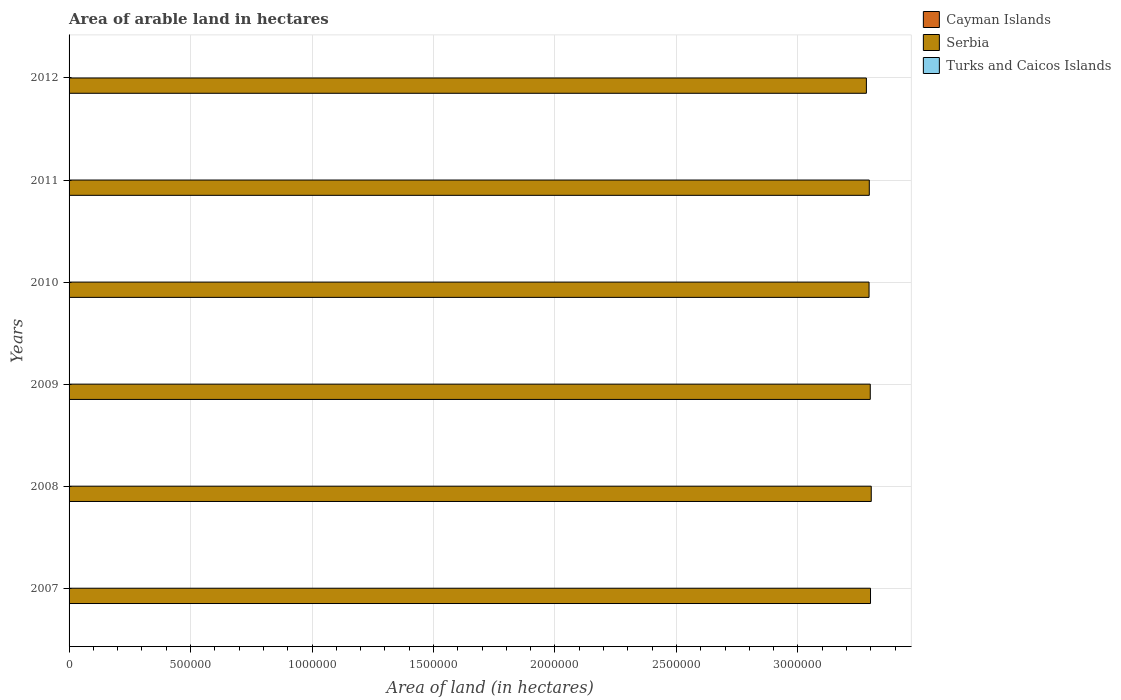How many groups of bars are there?
Your answer should be compact. 6. Are the number of bars on each tick of the Y-axis equal?
Make the answer very short. Yes. How many bars are there on the 1st tick from the bottom?
Your answer should be compact. 3. What is the total arable land in Serbia in 2010?
Offer a terse response. 3.29e+06. Across all years, what is the maximum total arable land in Serbia?
Ensure brevity in your answer.  3.30e+06. Across all years, what is the minimum total arable land in Serbia?
Keep it short and to the point. 3.28e+06. In which year was the total arable land in Turks and Caicos Islands minimum?
Ensure brevity in your answer.  2007. What is the total total arable land in Turks and Caicos Islands in the graph?
Provide a succinct answer. 6000. What is the difference between the total arable land in Cayman Islands in 2009 and the total arable land in Serbia in 2008?
Your answer should be very brief. -3.30e+06. What is the average total arable land in Cayman Islands per year?
Ensure brevity in your answer.  200. In the year 2011, what is the difference between the total arable land in Serbia and total arable land in Turks and Caicos Islands?
Your response must be concise. 3.29e+06. In how many years, is the total arable land in Serbia greater than 600000 hectares?
Your answer should be compact. 6. Is the total arable land in Turks and Caicos Islands in 2007 less than that in 2008?
Your answer should be compact. No. In how many years, is the total arable land in Cayman Islands greater than the average total arable land in Cayman Islands taken over all years?
Give a very brief answer. 0. Is the sum of the total arable land in Cayman Islands in 2007 and 2008 greater than the maximum total arable land in Serbia across all years?
Offer a terse response. No. What does the 3rd bar from the top in 2008 represents?
Provide a short and direct response. Cayman Islands. What does the 3rd bar from the bottom in 2009 represents?
Offer a very short reply. Turks and Caicos Islands. How many bars are there?
Keep it short and to the point. 18. Are all the bars in the graph horizontal?
Offer a very short reply. Yes. What is the difference between two consecutive major ticks on the X-axis?
Give a very brief answer. 5.00e+05. Are the values on the major ticks of X-axis written in scientific E-notation?
Your answer should be compact. No. Does the graph contain any zero values?
Give a very brief answer. No. Does the graph contain grids?
Provide a succinct answer. Yes. What is the title of the graph?
Give a very brief answer. Area of arable land in hectares. Does "Bolivia" appear as one of the legend labels in the graph?
Provide a short and direct response. No. What is the label or title of the X-axis?
Keep it short and to the point. Area of land (in hectares). What is the label or title of the Y-axis?
Your response must be concise. Years. What is the Area of land (in hectares) in Serbia in 2007?
Provide a succinct answer. 3.30e+06. What is the Area of land (in hectares) of Serbia in 2008?
Your response must be concise. 3.30e+06. What is the Area of land (in hectares) in Cayman Islands in 2009?
Your response must be concise. 200. What is the Area of land (in hectares) of Serbia in 2009?
Offer a terse response. 3.30e+06. What is the Area of land (in hectares) of Cayman Islands in 2010?
Give a very brief answer. 200. What is the Area of land (in hectares) of Serbia in 2010?
Make the answer very short. 3.29e+06. What is the Area of land (in hectares) in Turks and Caicos Islands in 2010?
Your answer should be very brief. 1000. What is the Area of land (in hectares) of Serbia in 2011?
Give a very brief answer. 3.29e+06. What is the Area of land (in hectares) of Cayman Islands in 2012?
Provide a succinct answer. 200. What is the Area of land (in hectares) of Serbia in 2012?
Your response must be concise. 3.28e+06. Across all years, what is the maximum Area of land (in hectares) of Cayman Islands?
Keep it short and to the point. 200. Across all years, what is the maximum Area of land (in hectares) in Serbia?
Your response must be concise. 3.30e+06. Across all years, what is the maximum Area of land (in hectares) of Turks and Caicos Islands?
Keep it short and to the point. 1000. Across all years, what is the minimum Area of land (in hectares) of Serbia?
Your answer should be very brief. 3.28e+06. Across all years, what is the minimum Area of land (in hectares) in Turks and Caicos Islands?
Offer a terse response. 1000. What is the total Area of land (in hectares) of Cayman Islands in the graph?
Keep it short and to the point. 1200. What is the total Area of land (in hectares) in Serbia in the graph?
Ensure brevity in your answer.  1.98e+07. What is the total Area of land (in hectares) in Turks and Caicos Islands in the graph?
Offer a very short reply. 6000. What is the difference between the Area of land (in hectares) of Serbia in 2007 and that in 2008?
Your response must be concise. -3000. What is the difference between the Area of land (in hectares) in Turks and Caicos Islands in 2007 and that in 2008?
Offer a very short reply. 0. What is the difference between the Area of land (in hectares) of Serbia in 2007 and that in 2009?
Offer a terse response. 1000. What is the difference between the Area of land (in hectares) in Turks and Caicos Islands in 2007 and that in 2009?
Provide a succinct answer. 0. What is the difference between the Area of land (in hectares) of Cayman Islands in 2007 and that in 2010?
Your answer should be very brief. 0. What is the difference between the Area of land (in hectares) in Serbia in 2007 and that in 2010?
Offer a terse response. 6000. What is the difference between the Area of land (in hectares) in Turks and Caicos Islands in 2007 and that in 2010?
Your answer should be compact. 0. What is the difference between the Area of land (in hectares) of Turks and Caicos Islands in 2007 and that in 2011?
Keep it short and to the point. 0. What is the difference between the Area of land (in hectares) of Serbia in 2007 and that in 2012?
Keep it short and to the point. 1.70e+04. What is the difference between the Area of land (in hectares) of Cayman Islands in 2008 and that in 2009?
Your answer should be compact. 0. What is the difference between the Area of land (in hectares) in Serbia in 2008 and that in 2009?
Give a very brief answer. 4000. What is the difference between the Area of land (in hectares) in Turks and Caicos Islands in 2008 and that in 2009?
Provide a succinct answer. 0. What is the difference between the Area of land (in hectares) in Cayman Islands in 2008 and that in 2010?
Offer a terse response. 0. What is the difference between the Area of land (in hectares) in Serbia in 2008 and that in 2010?
Provide a short and direct response. 9000. What is the difference between the Area of land (in hectares) of Cayman Islands in 2008 and that in 2011?
Your response must be concise. 0. What is the difference between the Area of land (in hectares) of Serbia in 2008 and that in 2011?
Ensure brevity in your answer.  8000. What is the difference between the Area of land (in hectares) of Turks and Caicos Islands in 2008 and that in 2011?
Ensure brevity in your answer.  0. What is the difference between the Area of land (in hectares) in Cayman Islands in 2008 and that in 2012?
Provide a short and direct response. 0. What is the difference between the Area of land (in hectares) of Turks and Caicos Islands in 2008 and that in 2012?
Your answer should be very brief. 0. What is the difference between the Area of land (in hectares) in Cayman Islands in 2009 and that in 2010?
Give a very brief answer. 0. What is the difference between the Area of land (in hectares) in Serbia in 2009 and that in 2010?
Provide a succinct answer. 5000. What is the difference between the Area of land (in hectares) of Turks and Caicos Islands in 2009 and that in 2010?
Your answer should be compact. 0. What is the difference between the Area of land (in hectares) in Serbia in 2009 and that in 2011?
Make the answer very short. 4000. What is the difference between the Area of land (in hectares) of Turks and Caicos Islands in 2009 and that in 2011?
Provide a succinct answer. 0. What is the difference between the Area of land (in hectares) of Cayman Islands in 2009 and that in 2012?
Ensure brevity in your answer.  0. What is the difference between the Area of land (in hectares) of Serbia in 2009 and that in 2012?
Your answer should be very brief. 1.60e+04. What is the difference between the Area of land (in hectares) in Turks and Caicos Islands in 2009 and that in 2012?
Offer a very short reply. 0. What is the difference between the Area of land (in hectares) in Cayman Islands in 2010 and that in 2011?
Your response must be concise. 0. What is the difference between the Area of land (in hectares) of Serbia in 2010 and that in 2011?
Ensure brevity in your answer.  -1000. What is the difference between the Area of land (in hectares) in Cayman Islands in 2010 and that in 2012?
Your answer should be compact. 0. What is the difference between the Area of land (in hectares) of Serbia in 2010 and that in 2012?
Offer a terse response. 1.10e+04. What is the difference between the Area of land (in hectares) of Turks and Caicos Islands in 2010 and that in 2012?
Your answer should be very brief. 0. What is the difference between the Area of land (in hectares) in Cayman Islands in 2011 and that in 2012?
Your response must be concise. 0. What is the difference between the Area of land (in hectares) in Serbia in 2011 and that in 2012?
Ensure brevity in your answer.  1.20e+04. What is the difference between the Area of land (in hectares) in Turks and Caicos Islands in 2011 and that in 2012?
Your answer should be compact. 0. What is the difference between the Area of land (in hectares) in Cayman Islands in 2007 and the Area of land (in hectares) in Serbia in 2008?
Make the answer very short. -3.30e+06. What is the difference between the Area of land (in hectares) of Cayman Islands in 2007 and the Area of land (in hectares) of Turks and Caicos Islands in 2008?
Offer a terse response. -800. What is the difference between the Area of land (in hectares) of Serbia in 2007 and the Area of land (in hectares) of Turks and Caicos Islands in 2008?
Give a very brief answer. 3.30e+06. What is the difference between the Area of land (in hectares) in Cayman Islands in 2007 and the Area of land (in hectares) in Serbia in 2009?
Provide a succinct answer. -3.30e+06. What is the difference between the Area of land (in hectares) of Cayman Islands in 2007 and the Area of land (in hectares) of Turks and Caicos Islands in 2009?
Keep it short and to the point. -800. What is the difference between the Area of land (in hectares) in Serbia in 2007 and the Area of land (in hectares) in Turks and Caicos Islands in 2009?
Provide a succinct answer. 3.30e+06. What is the difference between the Area of land (in hectares) in Cayman Islands in 2007 and the Area of land (in hectares) in Serbia in 2010?
Provide a succinct answer. -3.29e+06. What is the difference between the Area of land (in hectares) in Cayman Islands in 2007 and the Area of land (in hectares) in Turks and Caicos Islands in 2010?
Ensure brevity in your answer.  -800. What is the difference between the Area of land (in hectares) of Serbia in 2007 and the Area of land (in hectares) of Turks and Caicos Islands in 2010?
Your answer should be compact. 3.30e+06. What is the difference between the Area of land (in hectares) in Cayman Islands in 2007 and the Area of land (in hectares) in Serbia in 2011?
Keep it short and to the point. -3.29e+06. What is the difference between the Area of land (in hectares) in Cayman Islands in 2007 and the Area of land (in hectares) in Turks and Caicos Islands in 2011?
Your response must be concise. -800. What is the difference between the Area of land (in hectares) of Serbia in 2007 and the Area of land (in hectares) of Turks and Caicos Islands in 2011?
Your response must be concise. 3.30e+06. What is the difference between the Area of land (in hectares) of Cayman Islands in 2007 and the Area of land (in hectares) of Serbia in 2012?
Provide a short and direct response. -3.28e+06. What is the difference between the Area of land (in hectares) of Cayman Islands in 2007 and the Area of land (in hectares) of Turks and Caicos Islands in 2012?
Keep it short and to the point. -800. What is the difference between the Area of land (in hectares) of Serbia in 2007 and the Area of land (in hectares) of Turks and Caicos Islands in 2012?
Provide a short and direct response. 3.30e+06. What is the difference between the Area of land (in hectares) of Cayman Islands in 2008 and the Area of land (in hectares) of Serbia in 2009?
Provide a succinct answer. -3.30e+06. What is the difference between the Area of land (in hectares) of Cayman Islands in 2008 and the Area of land (in hectares) of Turks and Caicos Islands in 2009?
Give a very brief answer. -800. What is the difference between the Area of land (in hectares) in Serbia in 2008 and the Area of land (in hectares) in Turks and Caicos Islands in 2009?
Provide a short and direct response. 3.30e+06. What is the difference between the Area of land (in hectares) in Cayman Islands in 2008 and the Area of land (in hectares) in Serbia in 2010?
Provide a succinct answer. -3.29e+06. What is the difference between the Area of land (in hectares) of Cayman Islands in 2008 and the Area of land (in hectares) of Turks and Caicos Islands in 2010?
Offer a terse response. -800. What is the difference between the Area of land (in hectares) in Serbia in 2008 and the Area of land (in hectares) in Turks and Caicos Islands in 2010?
Your response must be concise. 3.30e+06. What is the difference between the Area of land (in hectares) of Cayman Islands in 2008 and the Area of land (in hectares) of Serbia in 2011?
Provide a succinct answer. -3.29e+06. What is the difference between the Area of land (in hectares) in Cayman Islands in 2008 and the Area of land (in hectares) in Turks and Caicos Islands in 2011?
Keep it short and to the point. -800. What is the difference between the Area of land (in hectares) in Serbia in 2008 and the Area of land (in hectares) in Turks and Caicos Islands in 2011?
Ensure brevity in your answer.  3.30e+06. What is the difference between the Area of land (in hectares) of Cayman Islands in 2008 and the Area of land (in hectares) of Serbia in 2012?
Offer a terse response. -3.28e+06. What is the difference between the Area of land (in hectares) in Cayman Islands in 2008 and the Area of land (in hectares) in Turks and Caicos Islands in 2012?
Provide a short and direct response. -800. What is the difference between the Area of land (in hectares) in Serbia in 2008 and the Area of land (in hectares) in Turks and Caicos Islands in 2012?
Keep it short and to the point. 3.30e+06. What is the difference between the Area of land (in hectares) in Cayman Islands in 2009 and the Area of land (in hectares) in Serbia in 2010?
Provide a succinct answer. -3.29e+06. What is the difference between the Area of land (in hectares) in Cayman Islands in 2009 and the Area of land (in hectares) in Turks and Caicos Islands in 2010?
Keep it short and to the point. -800. What is the difference between the Area of land (in hectares) in Serbia in 2009 and the Area of land (in hectares) in Turks and Caicos Islands in 2010?
Provide a short and direct response. 3.30e+06. What is the difference between the Area of land (in hectares) in Cayman Islands in 2009 and the Area of land (in hectares) in Serbia in 2011?
Provide a short and direct response. -3.29e+06. What is the difference between the Area of land (in hectares) of Cayman Islands in 2009 and the Area of land (in hectares) of Turks and Caicos Islands in 2011?
Make the answer very short. -800. What is the difference between the Area of land (in hectares) of Serbia in 2009 and the Area of land (in hectares) of Turks and Caicos Islands in 2011?
Offer a very short reply. 3.30e+06. What is the difference between the Area of land (in hectares) in Cayman Islands in 2009 and the Area of land (in hectares) in Serbia in 2012?
Keep it short and to the point. -3.28e+06. What is the difference between the Area of land (in hectares) of Cayman Islands in 2009 and the Area of land (in hectares) of Turks and Caicos Islands in 2012?
Your answer should be very brief. -800. What is the difference between the Area of land (in hectares) in Serbia in 2009 and the Area of land (in hectares) in Turks and Caicos Islands in 2012?
Offer a terse response. 3.30e+06. What is the difference between the Area of land (in hectares) of Cayman Islands in 2010 and the Area of land (in hectares) of Serbia in 2011?
Your response must be concise. -3.29e+06. What is the difference between the Area of land (in hectares) of Cayman Islands in 2010 and the Area of land (in hectares) of Turks and Caicos Islands in 2011?
Your answer should be compact. -800. What is the difference between the Area of land (in hectares) in Serbia in 2010 and the Area of land (in hectares) in Turks and Caicos Islands in 2011?
Provide a succinct answer. 3.29e+06. What is the difference between the Area of land (in hectares) in Cayman Islands in 2010 and the Area of land (in hectares) in Serbia in 2012?
Give a very brief answer. -3.28e+06. What is the difference between the Area of land (in hectares) in Cayman Islands in 2010 and the Area of land (in hectares) in Turks and Caicos Islands in 2012?
Make the answer very short. -800. What is the difference between the Area of land (in hectares) of Serbia in 2010 and the Area of land (in hectares) of Turks and Caicos Islands in 2012?
Make the answer very short. 3.29e+06. What is the difference between the Area of land (in hectares) of Cayman Islands in 2011 and the Area of land (in hectares) of Serbia in 2012?
Provide a succinct answer. -3.28e+06. What is the difference between the Area of land (in hectares) in Cayman Islands in 2011 and the Area of land (in hectares) in Turks and Caicos Islands in 2012?
Your answer should be compact. -800. What is the difference between the Area of land (in hectares) in Serbia in 2011 and the Area of land (in hectares) in Turks and Caicos Islands in 2012?
Ensure brevity in your answer.  3.29e+06. What is the average Area of land (in hectares) of Cayman Islands per year?
Give a very brief answer. 200. What is the average Area of land (in hectares) in Serbia per year?
Your answer should be compact. 3.29e+06. In the year 2007, what is the difference between the Area of land (in hectares) in Cayman Islands and Area of land (in hectares) in Serbia?
Offer a very short reply. -3.30e+06. In the year 2007, what is the difference between the Area of land (in hectares) in Cayman Islands and Area of land (in hectares) in Turks and Caicos Islands?
Your response must be concise. -800. In the year 2007, what is the difference between the Area of land (in hectares) of Serbia and Area of land (in hectares) of Turks and Caicos Islands?
Provide a short and direct response. 3.30e+06. In the year 2008, what is the difference between the Area of land (in hectares) in Cayman Islands and Area of land (in hectares) in Serbia?
Your answer should be compact. -3.30e+06. In the year 2008, what is the difference between the Area of land (in hectares) in Cayman Islands and Area of land (in hectares) in Turks and Caicos Islands?
Your answer should be compact. -800. In the year 2008, what is the difference between the Area of land (in hectares) in Serbia and Area of land (in hectares) in Turks and Caicos Islands?
Provide a succinct answer. 3.30e+06. In the year 2009, what is the difference between the Area of land (in hectares) of Cayman Islands and Area of land (in hectares) of Serbia?
Make the answer very short. -3.30e+06. In the year 2009, what is the difference between the Area of land (in hectares) of Cayman Islands and Area of land (in hectares) of Turks and Caicos Islands?
Ensure brevity in your answer.  -800. In the year 2009, what is the difference between the Area of land (in hectares) in Serbia and Area of land (in hectares) in Turks and Caicos Islands?
Make the answer very short. 3.30e+06. In the year 2010, what is the difference between the Area of land (in hectares) of Cayman Islands and Area of land (in hectares) of Serbia?
Provide a short and direct response. -3.29e+06. In the year 2010, what is the difference between the Area of land (in hectares) of Cayman Islands and Area of land (in hectares) of Turks and Caicos Islands?
Offer a terse response. -800. In the year 2010, what is the difference between the Area of land (in hectares) of Serbia and Area of land (in hectares) of Turks and Caicos Islands?
Give a very brief answer. 3.29e+06. In the year 2011, what is the difference between the Area of land (in hectares) in Cayman Islands and Area of land (in hectares) in Serbia?
Ensure brevity in your answer.  -3.29e+06. In the year 2011, what is the difference between the Area of land (in hectares) in Cayman Islands and Area of land (in hectares) in Turks and Caicos Islands?
Your answer should be compact. -800. In the year 2011, what is the difference between the Area of land (in hectares) in Serbia and Area of land (in hectares) in Turks and Caicos Islands?
Ensure brevity in your answer.  3.29e+06. In the year 2012, what is the difference between the Area of land (in hectares) in Cayman Islands and Area of land (in hectares) in Serbia?
Ensure brevity in your answer.  -3.28e+06. In the year 2012, what is the difference between the Area of land (in hectares) in Cayman Islands and Area of land (in hectares) in Turks and Caicos Islands?
Offer a terse response. -800. In the year 2012, what is the difference between the Area of land (in hectares) in Serbia and Area of land (in hectares) in Turks and Caicos Islands?
Your answer should be very brief. 3.28e+06. What is the ratio of the Area of land (in hectares) in Cayman Islands in 2007 to that in 2009?
Your answer should be compact. 1. What is the ratio of the Area of land (in hectares) in Serbia in 2007 to that in 2009?
Offer a very short reply. 1. What is the ratio of the Area of land (in hectares) in Serbia in 2007 to that in 2011?
Provide a succinct answer. 1. What is the ratio of the Area of land (in hectares) of Turks and Caicos Islands in 2007 to that in 2011?
Offer a very short reply. 1. What is the ratio of the Area of land (in hectares) in Turks and Caicos Islands in 2007 to that in 2012?
Make the answer very short. 1. What is the ratio of the Area of land (in hectares) of Cayman Islands in 2008 to that in 2010?
Your answer should be very brief. 1. What is the ratio of the Area of land (in hectares) in Turks and Caicos Islands in 2008 to that in 2010?
Offer a terse response. 1. What is the ratio of the Area of land (in hectares) in Cayman Islands in 2008 to that in 2011?
Your answer should be compact. 1. What is the ratio of the Area of land (in hectares) of Cayman Islands in 2008 to that in 2012?
Give a very brief answer. 1. What is the ratio of the Area of land (in hectares) in Serbia in 2008 to that in 2012?
Offer a terse response. 1.01. What is the ratio of the Area of land (in hectares) of Turks and Caicos Islands in 2008 to that in 2012?
Provide a succinct answer. 1. What is the ratio of the Area of land (in hectares) in Serbia in 2009 to that in 2010?
Ensure brevity in your answer.  1. What is the ratio of the Area of land (in hectares) in Cayman Islands in 2009 to that in 2011?
Provide a succinct answer. 1. What is the ratio of the Area of land (in hectares) in Serbia in 2009 to that in 2011?
Make the answer very short. 1. What is the ratio of the Area of land (in hectares) of Turks and Caicos Islands in 2009 to that in 2011?
Ensure brevity in your answer.  1. What is the ratio of the Area of land (in hectares) in Cayman Islands in 2010 to that in 2012?
Your response must be concise. 1. What is the ratio of the Area of land (in hectares) of Turks and Caicos Islands in 2010 to that in 2012?
Your answer should be very brief. 1. What is the ratio of the Area of land (in hectares) of Cayman Islands in 2011 to that in 2012?
Give a very brief answer. 1. What is the difference between the highest and the second highest Area of land (in hectares) of Serbia?
Offer a terse response. 3000. What is the difference between the highest and the lowest Area of land (in hectares) of Cayman Islands?
Provide a succinct answer. 0. 